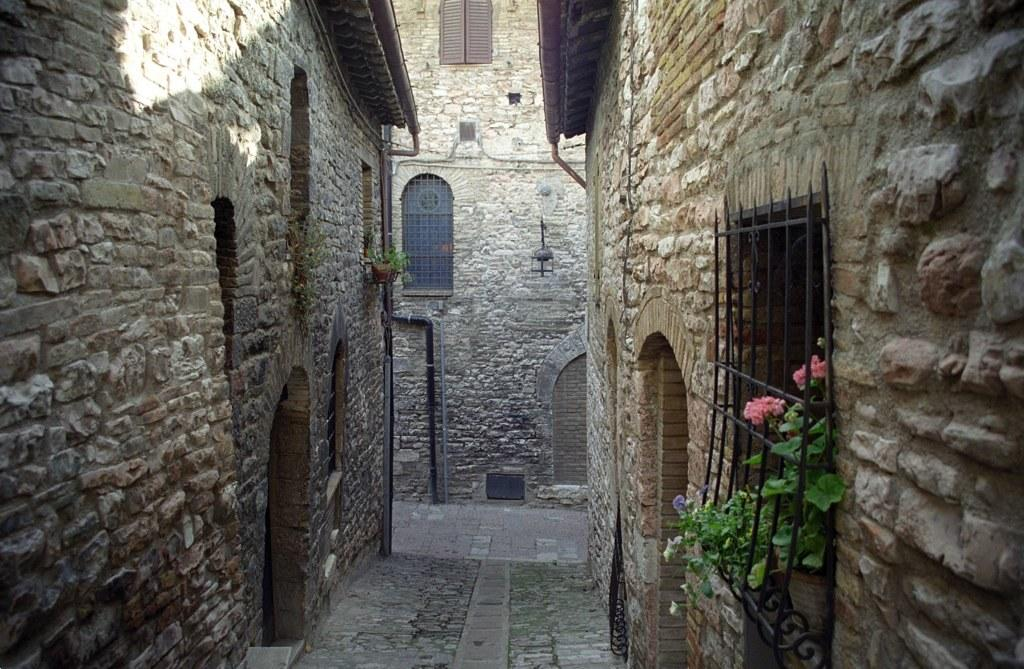What type of buildings are visible in the image? There are stone buildings in the image. What feature do the stone buildings have? The buildings have windows. What type of plant can be seen in the image? There is a flower plant in the image. What is the purpose of the fence in the image? The fence is present in the image, but its purpose cannot be definitively determined from the provided facts. What type of corn can be seen growing near the stone buildings in the image? There is no corn visible in the image; only stone buildings, windows, a flower plant, and a fence are present. 